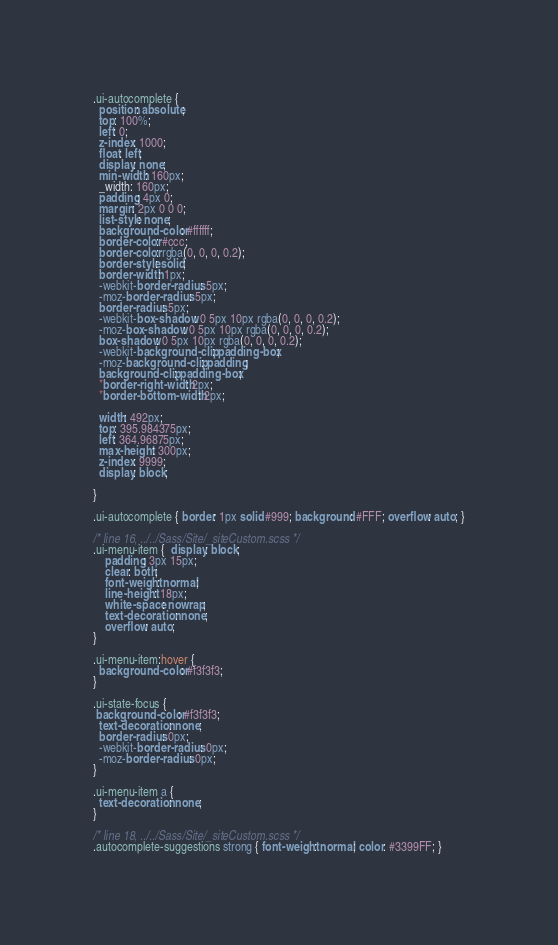<code> <loc_0><loc_0><loc_500><loc_500><_CSS_>.ui-autocomplete {
  position: absolute;
  top: 100%;
  left: 0;
  z-index: 1000;
  float: left;
  display: none;
  min-width: 160px;
  _width: 160px;
  padding: 4px 0;
  margin: 2px 0 0 0;
  list-style: none;
  background-color: #ffffff;
  border-color: #ccc;
  border-color: rgba(0, 0, 0, 0.2);
  border-style: solid;
  border-width: 1px;
  -webkit-border-radius: 5px;
  -moz-border-radius: 5px;
  border-radius: 5px;
  -webkit-box-shadow: 0 5px 10px rgba(0, 0, 0, 0.2);
  -moz-box-shadow: 0 5px 10px rgba(0, 0, 0, 0.2);
  box-shadow: 0 5px 10px rgba(0, 0, 0, 0.2);
  -webkit-background-clip: padding-box;
  -moz-background-clip: padding;
  background-clip: padding-box;
  *border-right-width: 2px;
  *border-bottom-width: 2px;

  width: 492px;
  top: 395.984375px;
  left: 364.96875px;
  max-height: 300px;
  z-index: 9999;
  display: block;
 
}

.ui-autocomplete { border: 1px solid #999; background: #FFF; overflow: auto; }

/* line 16, ../../Sass/Site/_siteCustom.scss */
.ui-menu-item {  display: block;
    padding: 3px 15px;
    clear: both;
    font-weight: normal;
    line-height: 18px;    
    white-space: nowrap; 
    text-decoration: none;
    overflow: auto;
}

.ui-menu-item:hover {
  background-color: #f3f3f3;
}

.ui-state-focus {
 background-color: #f3f3f3;
  text-decoration: none;
  border-radius: 0px;
  -webkit-border-radius: 0px;
  -moz-border-radius: 0px;
}

.ui-menu-item a {
  text-decoration: none;
}

/* line 18, ../../Sass/Site/_siteCustom.scss */
.autocomplete-suggestions strong { font-weight: normal; color: #3399FF; }</code> 